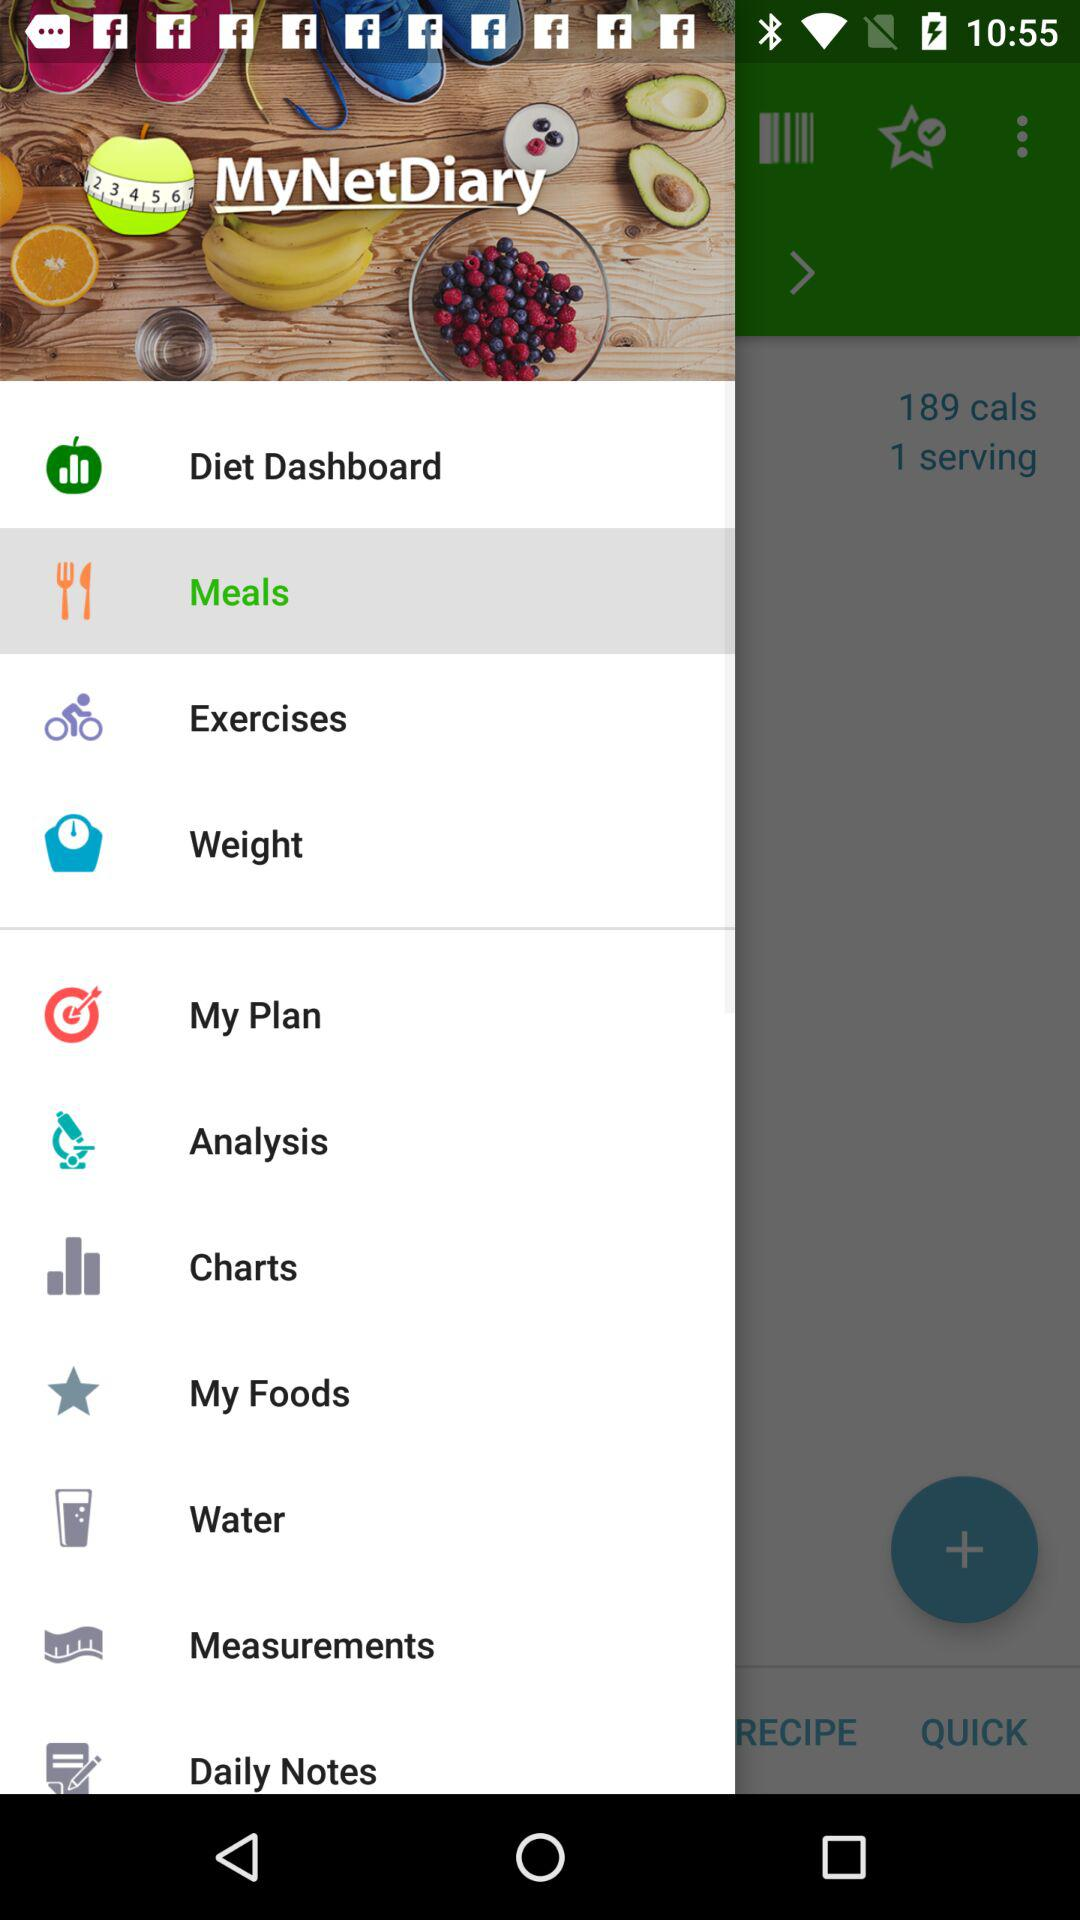What is the name of the application? The name of the application is "MyNetDiary". 